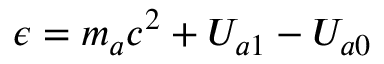Convert formula to latex. <formula><loc_0><loc_0><loc_500><loc_500>\epsilon = m _ { a } c ^ { 2 } + U _ { a 1 } - U _ { a 0 }</formula> 